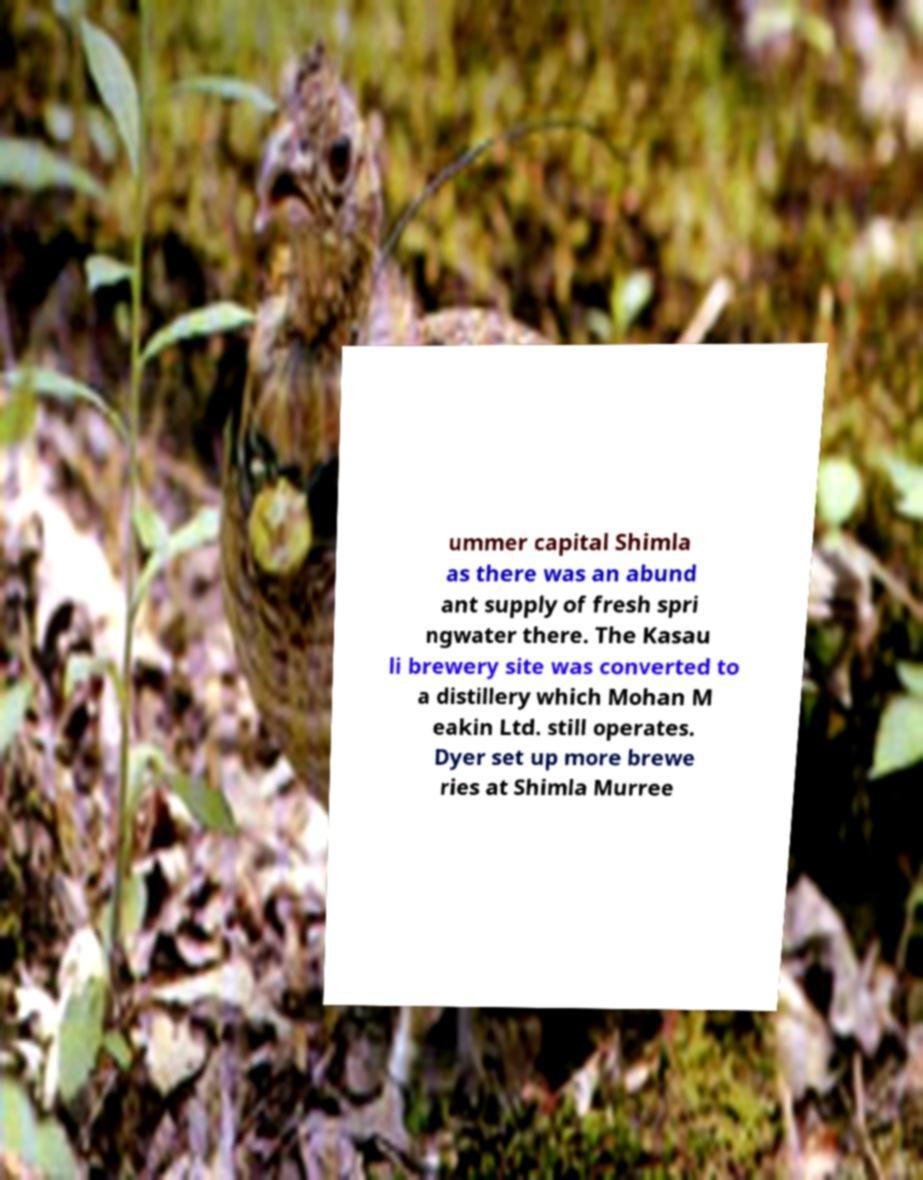There's text embedded in this image that I need extracted. Can you transcribe it verbatim? ummer capital Shimla as there was an abund ant supply of fresh spri ngwater there. The Kasau li brewery site was converted to a distillery which Mohan M eakin Ltd. still operates. Dyer set up more brewe ries at Shimla Murree 